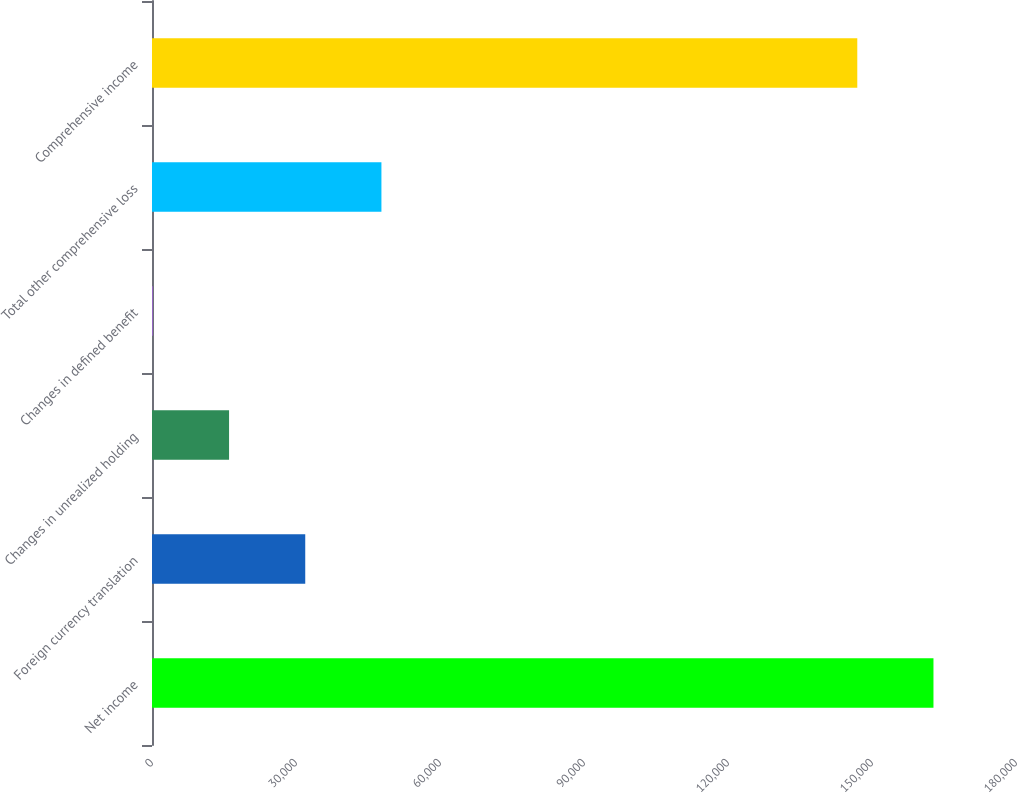<chart> <loc_0><loc_0><loc_500><loc_500><bar_chart><fcel>Net income<fcel>Foreign currency translation<fcel>Changes in unrealized holding<fcel>Changes in defined benefit<fcel>Total other comprehensive loss<fcel>Comprehensive income<nl><fcel>162806<fcel>31926<fcel>16054.5<fcel>183<fcel>47797.5<fcel>146934<nl></chart> 